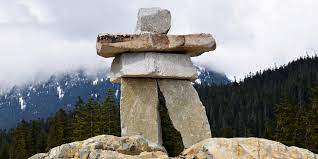Can you tell me more about the location where this Inukshuk is situated? This Inukshuk is located in a mountainous region that could be part of the Canadian Rockies. The thick forests and the snow-capped mountains suggest an area with harsh winters but beautiful natural scenery. These regions are often chosen for Inukshuks due to their visibility and significance in marking important locational or spiritual sites in large, open landscapes. 